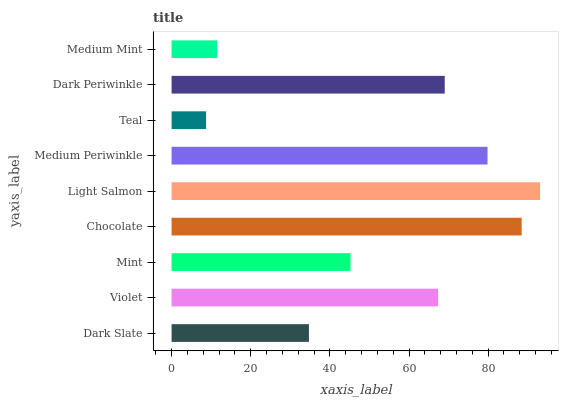Is Teal the minimum?
Answer yes or no. Yes. Is Light Salmon the maximum?
Answer yes or no. Yes. Is Violet the minimum?
Answer yes or no. No. Is Violet the maximum?
Answer yes or no. No. Is Violet greater than Dark Slate?
Answer yes or no. Yes. Is Dark Slate less than Violet?
Answer yes or no. Yes. Is Dark Slate greater than Violet?
Answer yes or no. No. Is Violet less than Dark Slate?
Answer yes or no. No. Is Violet the high median?
Answer yes or no. Yes. Is Violet the low median?
Answer yes or no. Yes. Is Light Salmon the high median?
Answer yes or no. No. Is Medium Mint the low median?
Answer yes or no. No. 